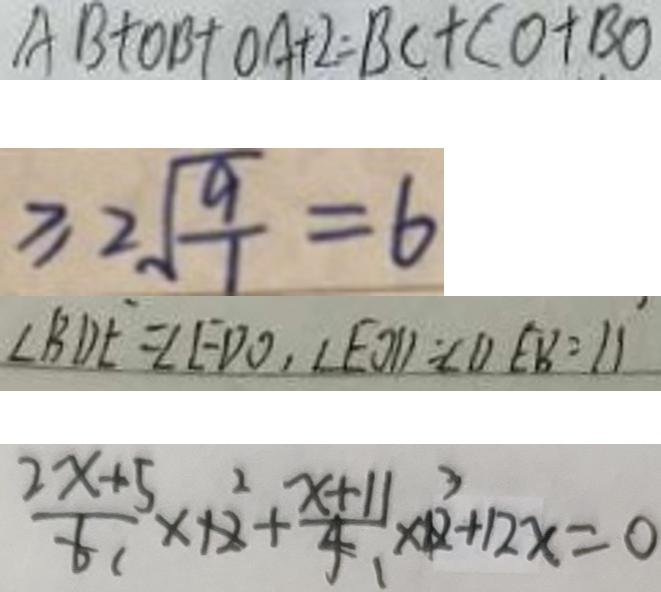<formula> <loc_0><loc_0><loc_500><loc_500>A B + O B + O A + 2 = B C + C O + B O 
 \geq 2 \sqrt { \frac { 9 } { 1 } } = 6 
 \angle B D E = \angle E D O , \angle E O D = \angle D E B = 1 1 
 \frac { 2 x + 5 } { 6 } \times 1 2 + \frac { x + 1 1 } { 4 } \times 1 2 + 1 2 x = 0</formula> 